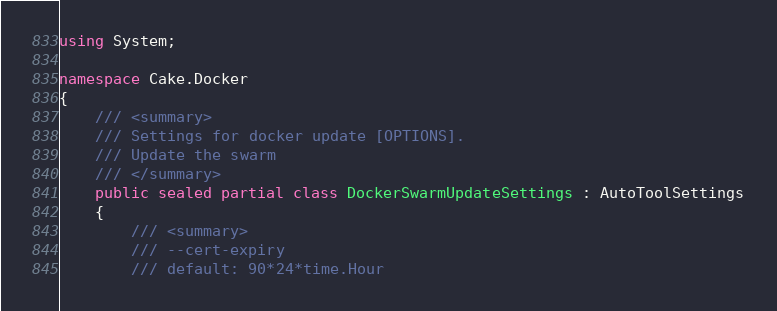Convert code to text. <code><loc_0><loc_0><loc_500><loc_500><_C#_>using System;

namespace Cake.Docker
{
	/// <summary>
	/// Settings for docker update [OPTIONS].
	/// Update the swarm
	/// </summary>
	public sealed partial class DockerSwarmUpdateSettings : AutoToolSettings
	{
		/// <summary>
		/// --cert-expiry
		/// default: 90*24*time.Hour</code> 